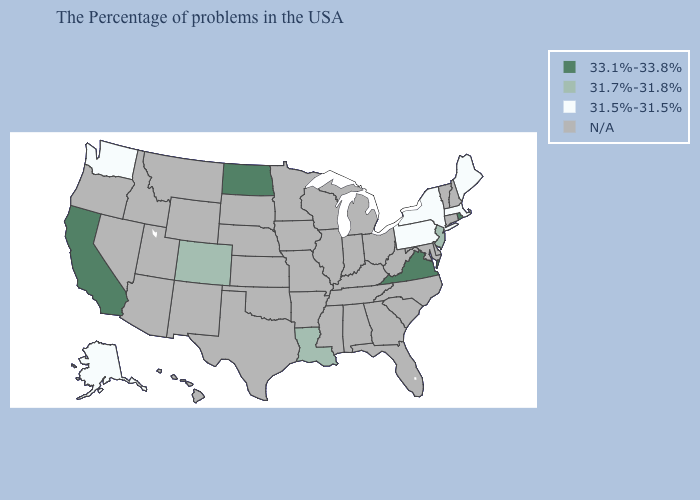Is the legend a continuous bar?
Concise answer only. No. Name the states that have a value in the range 31.7%-31.8%?
Keep it brief. New Jersey, Louisiana, Colorado. What is the value of California?
Write a very short answer. 33.1%-33.8%. What is the highest value in states that border Utah?
Keep it brief. 31.7%-31.8%. Name the states that have a value in the range 33.1%-33.8%?
Write a very short answer. Rhode Island, Virginia, North Dakota, California. What is the value of Idaho?
Short answer required. N/A. Which states have the highest value in the USA?
Answer briefly. Rhode Island, Virginia, North Dakota, California. Name the states that have a value in the range 31.5%-31.5%?
Short answer required. Maine, Massachusetts, New York, Pennsylvania, Washington, Alaska. Among the states that border New Hampshire , which have the lowest value?
Concise answer only. Maine, Massachusetts. What is the value of Utah?
Be succinct. N/A. Name the states that have a value in the range 31.7%-31.8%?
Concise answer only. New Jersey, Louisiana, Colorado. Which states hav the highest value in the Northeast?
Be succinct. Rhode Island. Does Washington have the lowest value in the USA?
Quick response, please. Yes. 